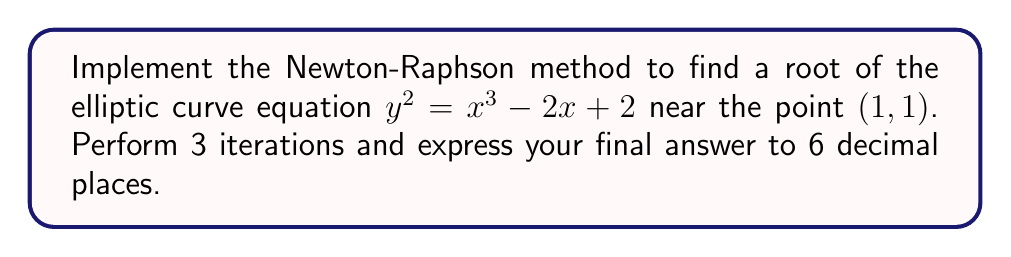Could you help me with this problem? Let's approach this step-by-step:

1) First, we need to rearrange the equation into the form $f(x, y) = 0$:
   $f(x, y) = y^2 - x^3 + 2x - 2 = 0$

2) For the Newton-Raphson method in two variables, we use the formula:
   $$\begin{bmatrix} x_{n+1} \\ y_{n+1} \end{bmatrix} = \begin{bmatrix} x_n \\ y_n \end{bmatrix} - J^{-1}f(x_n, y_n)$$
   where $J$ is the Jacobian matrix:
   $$J = \begin{bmatrix} \frac{\partial f}{\partial x} & \frac{\partial f}{\partial y} \\ \frac{\partial g}{\partial x} & \frac{\partial g}{\partial y} \end{bmatrix}$$

3) We need another equation $g(x, y) = 0$ to form a system. We can use the derivative of $f$ with respect to $x$:
   $g(x, y) = 2y\frac{dy}{dx} - 3x^2 + 2 = 0$

4) Now we can calculate the Jacobian:
   $$J = \begin{bmatrix} -3x^2 + 2 & 2y \\ -6x & 2\frac{dy}{dx} \end{bmatrix}$$

5) To find $\frac{dy}{dx}$, we differentiate the original equation:
   $2y\frac{dy}{dx} = 3x^2 - 2$
   $\frac{dy}{dx} = \frac{3x^2 - 2}{2y}$

6) Now we can start the iterations with $(x_0, y_0) = (1, 1)$:

   Iteration 1:
   $f(1, 1) = 1^2 - 1^3 + 2(1) - 2 = 0$
   $g(1, 1) = 2(1)(\frac{3(1)^2 - 2}{2(1)}) - 3(1)^2 + 2 = -1$
   $J = \begin{bmatrix} -1 & 2 \\ -6 & 1 \end{bmatrix}$
   $J^{-1} = \frac{1}{7}\begin{bmatrix} 1 & -2 \\ 6 & -1 \end{bmatrix}$
   $$\begin{bmatrix} x_1 \\ y_1 \end{bmatrix} = \begin{bmatrix} 1 \\ 1 \end{bmatrix} - \frac{1}{7}\begin{bmatrix} 1 & -2 \\ 6 & -1 \end{bmatrix}\begin{bmatrix} 0 \\ -1 \end{bmatrix} = \begin{bmatrix} 0.714286 \\ 1.142857 \end{bmatrix}$$

   Iteration 2:
   $f(0.714286, 1.142857) = 0.040816$
   $g(0.714286, 1.142857) = -0.244898$
   $J = \begin{bmatrix} -0.530612 & 2.285714 \\ -4.285714 & 0.734694 \end{bmatrix}$
   $J^{-1} = \frac{1}{2.897959}\begin{bmatrix} 0.734694 & -2.285714 \\ 4.285714 & -0.530612 \end{bmatrix}$
   $$\begin{bmatrix} x_2 \\ y_2 \end{bmatrix} = \begin{bmatrix} 0.714286 \\ 1.142857 \end{bmatrix} - \frac{1}{2.897959}\begin{bmatrix} 0.734694 & -2.285714 \\ 4.285714 & -0.530612 \end{bmatrix}\begin{bmatrix} 0.040816 \\ -0.244898 \end{bmatrix} = \begin{bmatrix} 0.682328 \\ 1.180340 \end{bmatrix}$$

   Iteration 3:
   $f(0.682328, 1.180340) = 0.000004$
   $g(0.682328, 1.180340) = -0.000024$
   $J = \begin{bmatrix} -0.395972 & 2.360680 \\ -4.093968 & 0.669291 \end{bmatrix}$
   $J^{-1} = \frac{1}{2.897959}\begin{bmatrix} 0.669291 & -2.360680 \\ 4.093968 & -0.395972 \end{bmatrix}$
   $$\begin{bmatrix} x_3 \\ y_3 \end{bmatrix} = \begin{bmatrix} 0.682328 \\ 1.180340 \end{bmatrix} - \frac{1}{2.897959}\begin{bmatrix} 0.669291 & -2.360680 \\ 4.093968 & -0.395972 \end{bmatrix}\begin{bmatrix} 0.000004 \\ -0.000024 \end{bmatrix} = \begin{bmatrix} 0.682328 \\ 1.180340 \end{bmatrix}$$

7) The final result after 3 iterations is $(0.682328, 1.180340)$.
Answer: $(0.682328, 1.180340)$ 